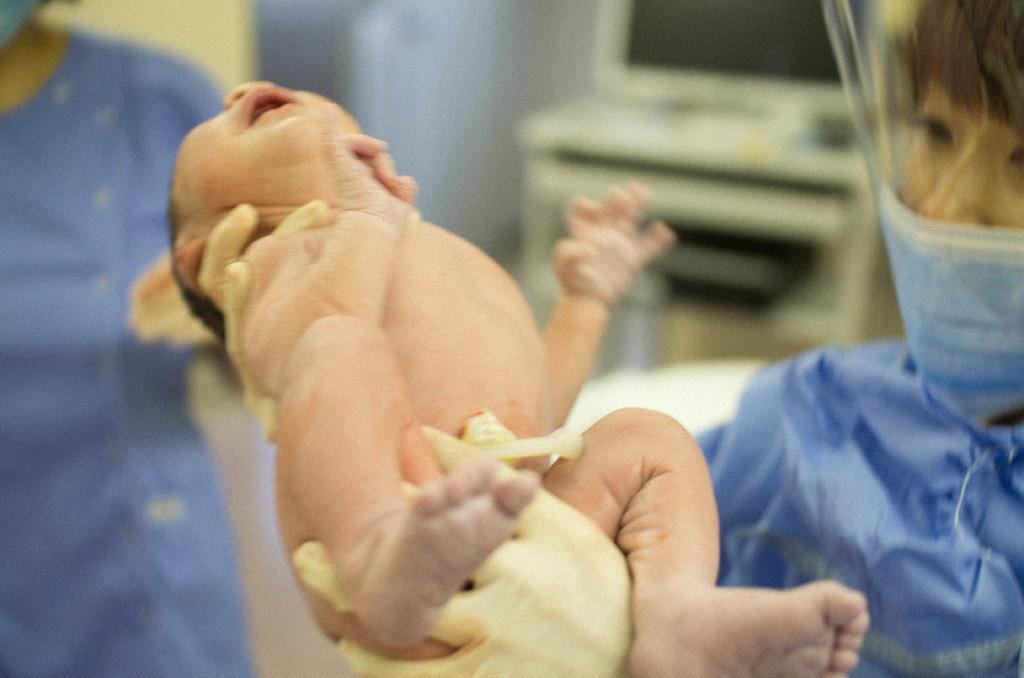What is the person in the image holding? The person in the image is holding a baby. Can you describe the position of the other person in the image? There is another person standing on the left side of the image. What can be seen in the background of the image? There is a computer placed on a stand in the background of the image. What type of tin is being used to connect the two nations in the image? There is no tin or connection between two nations present in the image. 